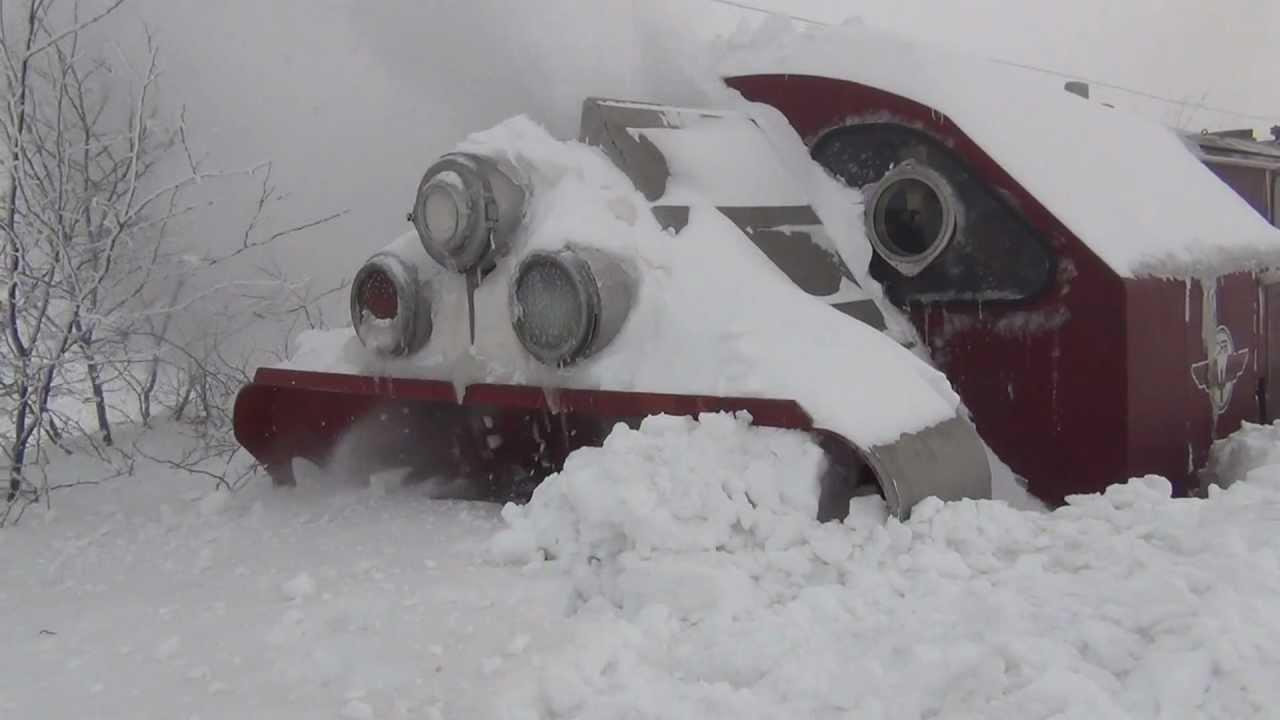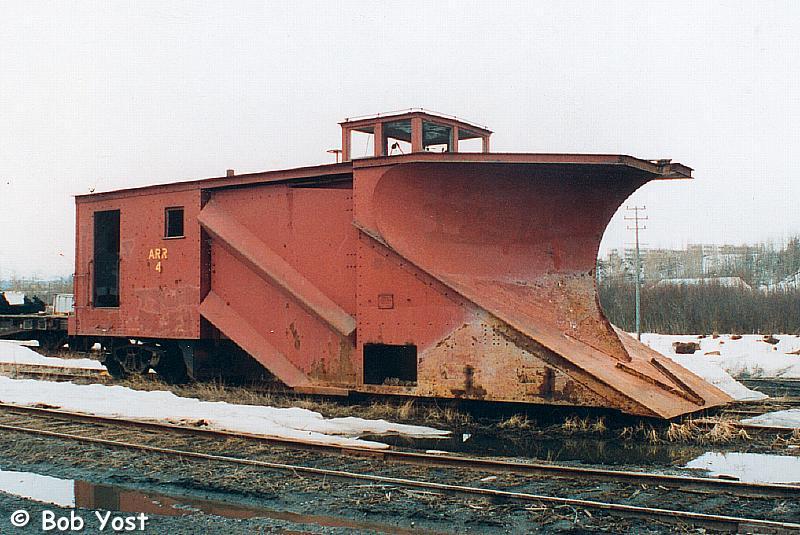The first image is the image on the left, the second image is the image on the right. Evaluate the accuracy of this statement regarding the images: "Snow covers the area in each of the images.". Is it true? Answer yes or no. Yes. The first image is the image on the left, the second image is the image on the right. Evaluate the accuracy of this statement regarding the images: "The left and right image contains the same number of black trains.". Is it true? Answer yes or no. No. 